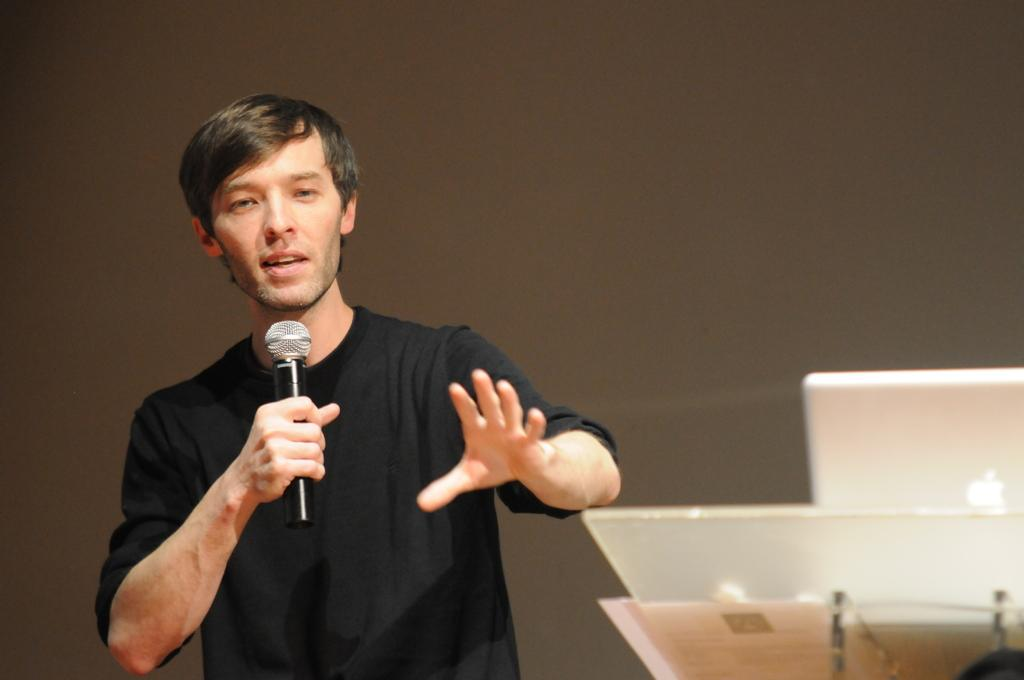Who is the main subject in the image? There is a man in the image. What is the man wearing? The man is wearing a black shirt. What is the man doing in the image? The man is talking into a microphone. What other objects can be seen in the image? There is a laptop on the right side of the image and a podium in the image. What type of brass instrument is the man playing in the image? There is no brass instrument present in the image; the man is talking into a microphone. Can you tell me how the man's father is involved in the scene? There is no mention of the man's father in the image or the provided facts. 